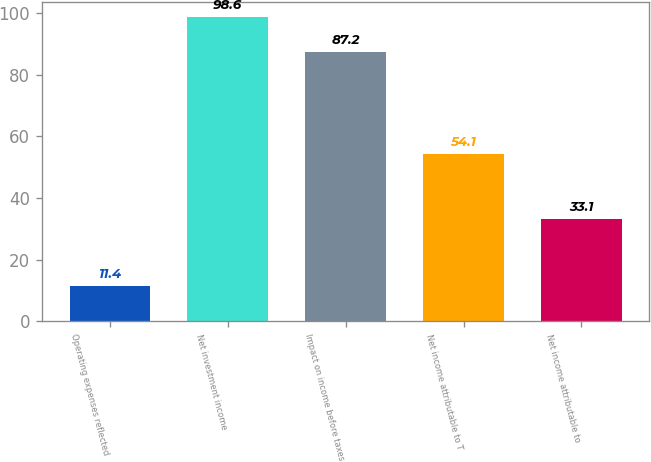Convert chart. <chart><loc_0><loc_0><loc_500><loc_500><bar_chart><fcel>Operating expenses reflected<fcel>Net investment income<fcel>Impact on income before taxes<fcel>Net income attributable to T<fcel>Net income attributable to<nl><fcel>11.4<fcel>98.6<fcel>87.2<fcel>54.1<fcel>33.1<nl></chart> 